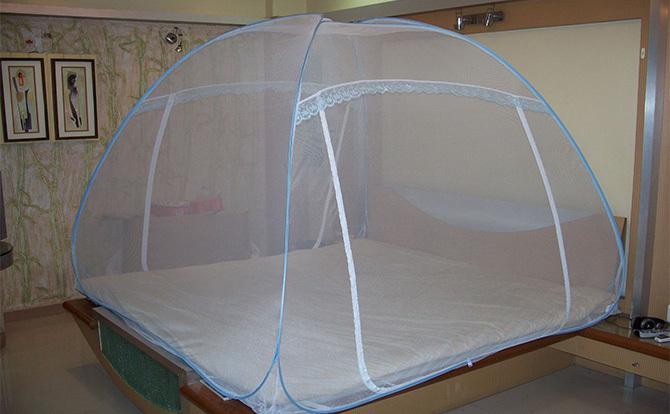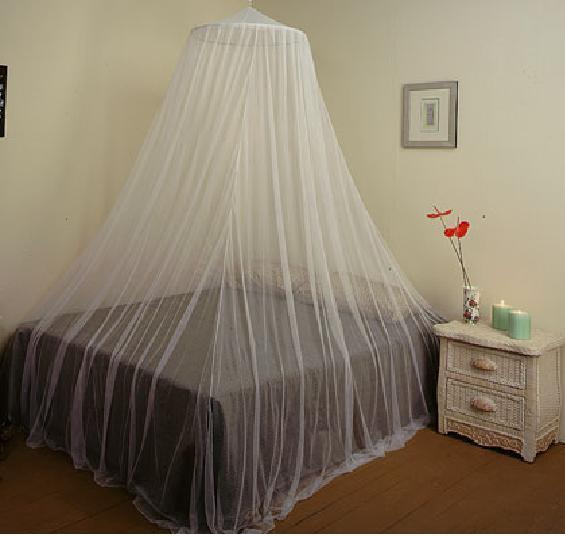The first image is the image on the left, the second image is the image on the right. For the images displayed, is the sentence "Both nets enclose the beds." factually correct? Answer yes or no. Yes. 